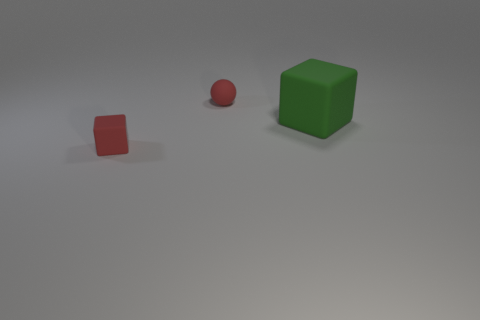Add 3 rubber balls. How many objects exist? 6 Subtract all cubes. How many objects are left? 1 Subtract 0 purple blocks. How many objects are left? 3 Subtract all red blocks. Subtract all big rubber things. How many objects are left? 1 Add 3 cubes. How many cubes are left? 5 Add 3 tiny red rubber cubes. How many tiny red rubber cubes exist? 4 